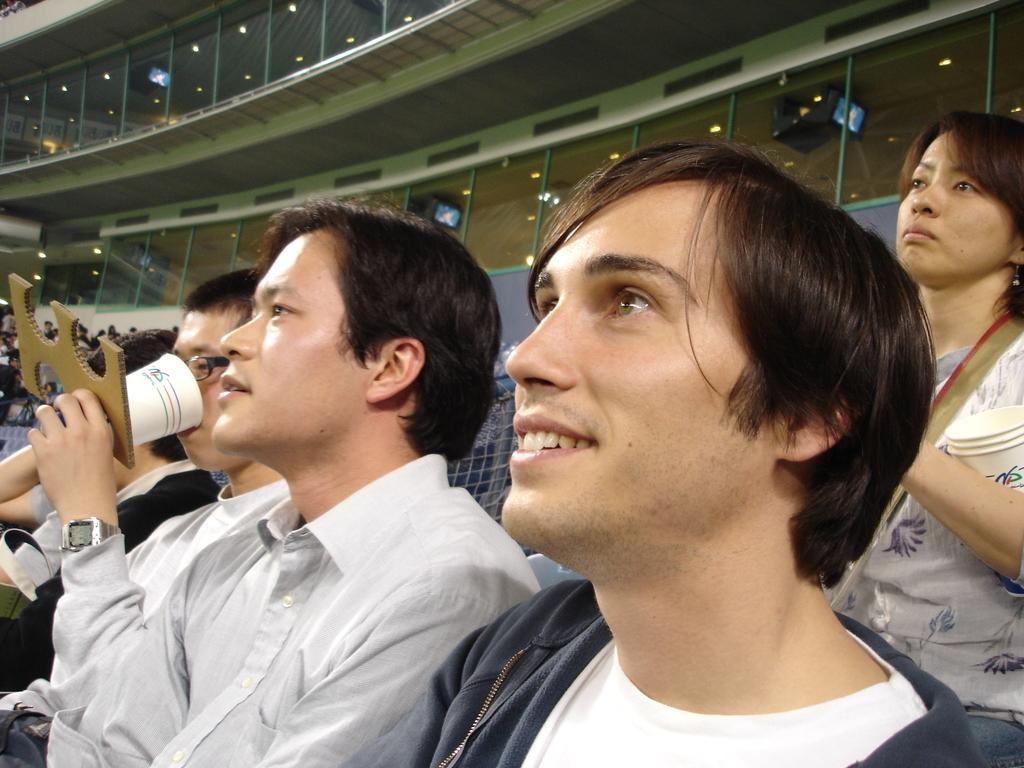What are the people in the image doing? The people in the image are sitting on chairs. Can you describe the woman in the image? There is a woman standing on the right side of the image. What can be seen in the background of the image? There are glass windows in the background of the image. What type of oven is visible in the image? There is no oven present in the image. 